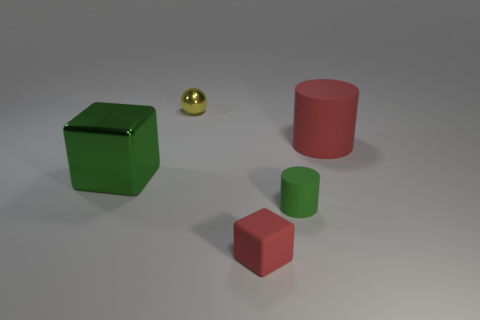Add 4 yellow metal objects. How many objects exist? 9 Subtract all blocks. How many objects are left? 3 Subtract 0 cyan cylinders. How many objects are left? 5 Subtract all gray metallic things. Subtract all yellow spheres. How many objects are left? 4 Add 1 metal objects. How many metal objects are left? 3 Add 1 tiny yellow shiny things. How many tiny yellow shiny things exist? 2 